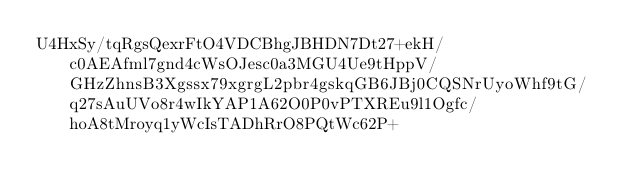<code> <loc_0><loc_0><loc_500><loc_500><_SML_>U4HxSy/tqRgsQexrFtO4VDCBhgJBHDN7Dt27+ekH/c0AEAfml7gnd4cWsOJesc0a3MGU4Ue9tHppV/GHzZhnsB3Xgssx79xgrgL2pbr4gskqGB6JBj0CQSNrUyoWhf9tG/q27sAuUVo8r4wIkYAP1A62O0P0vPTXREu9l1Ogfc/hoA8tMroyq1yWcIsTADhRrO8PQtWc62P+</code> 